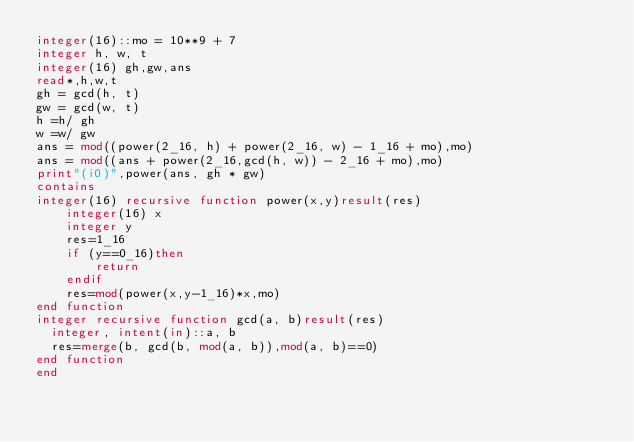Convert code to text. <code><loc_0><loc_0><loc_500><loc_500><_FORTRAN_>integer(16)::mo = 10**9 + 7
integer h, w, t
integer(16) gh,gw,ans
read*,h,w,t
gh = gcd(h, t)
gw = gcd(w, t)
h =h/ gh
w =w/ gw
ans = mod((power(2_16, h) + power(2_16, w) - 1_16 + mo),mo)
ans = mod((ans + power(2_16,gcd(h, w)) - 2_16 + mo),mo) 
print"(i0)",power(ans, gh * gw)
contains
integer(16) recursive function power(x,y)result(res)
    integer(16) x
    integer y
    res=1_16
    if (y==0_16)then
        return
    endif
    res=mod(power(x,y-1_16)*x,mo)
end function
integer recursive function gcd(a, b)result(res)
  integer, intent(in)::a, b
  res=merge(b, gcd(b, mod(a, b)),mod(a, b)==0)
end function
end </code> 